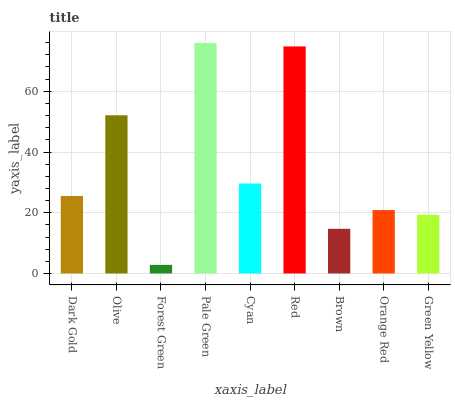Is Forest Green the minimum?
Answer yes or no. Yes. Is Pale Green the maximum?
Answer yes or no. Yes. Is Olive the minimum?
Answer yes or no. No. Is Olive the maximum?
Answer yes or no. No. Is Olive greater than Dark Gold?
Answer yes or no. Yes. Is Dark Gold less than Olive?
Answer yes or no. Yes. Is Dark Gold greater than Olive?
Answer yes or no. No. Is Olive less than Dark Gold?
Answer yes or no. No. Is Dark Gold the high median?
Answer yes or no. Yes. Is Dark Gold the low median?
Answer yes or no. Yes. Is Olive the high median?
Answer yes or no. No. Is Olive the low median?
Answer yes or no. No. 